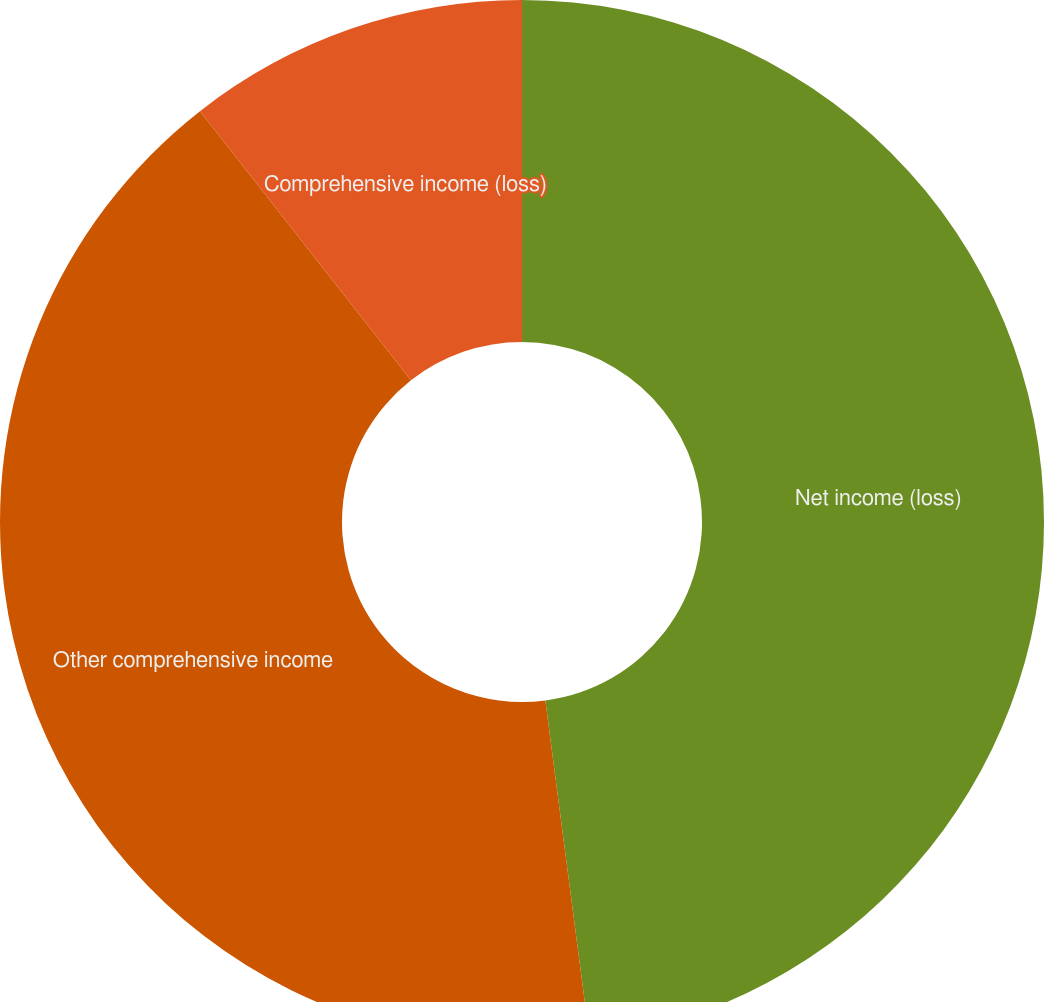<chart> <loc_0><loc_0><loc_500><loc_500><pie_chart><fcel>Net income (loss)<fcel>Other comprehensive income<fcel>Comprehensive income (loss)<nl><fcel>47.93%<fcel>41.49%<fcel>10.58%<nl></chart> 